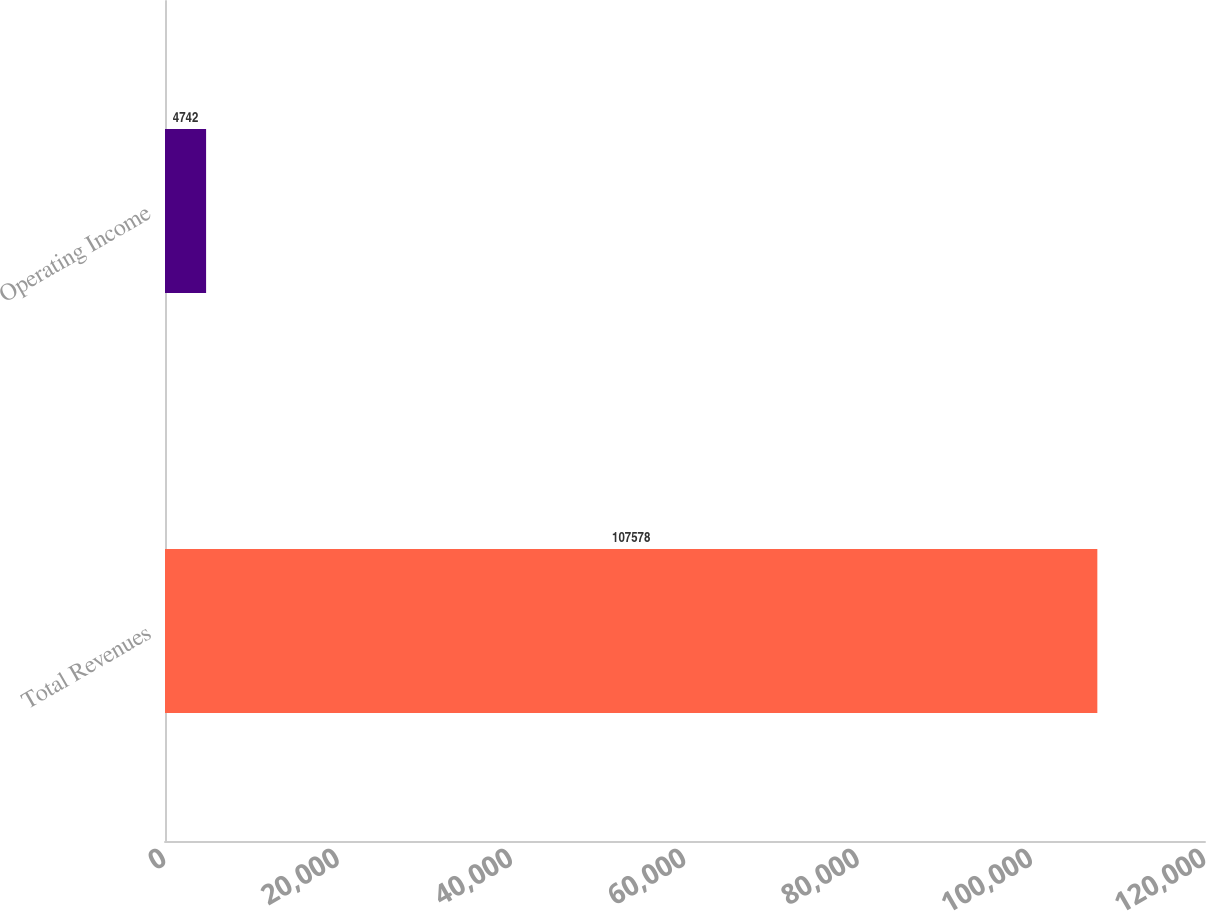Convert chart to OTSL. <chart><loc_0><loc_0><loc_500><loc_500><bar_chart><fcel>Total Revenues<fcel>Operating Income<nl><fcel>107578<fcel>4742<nl></chart> 